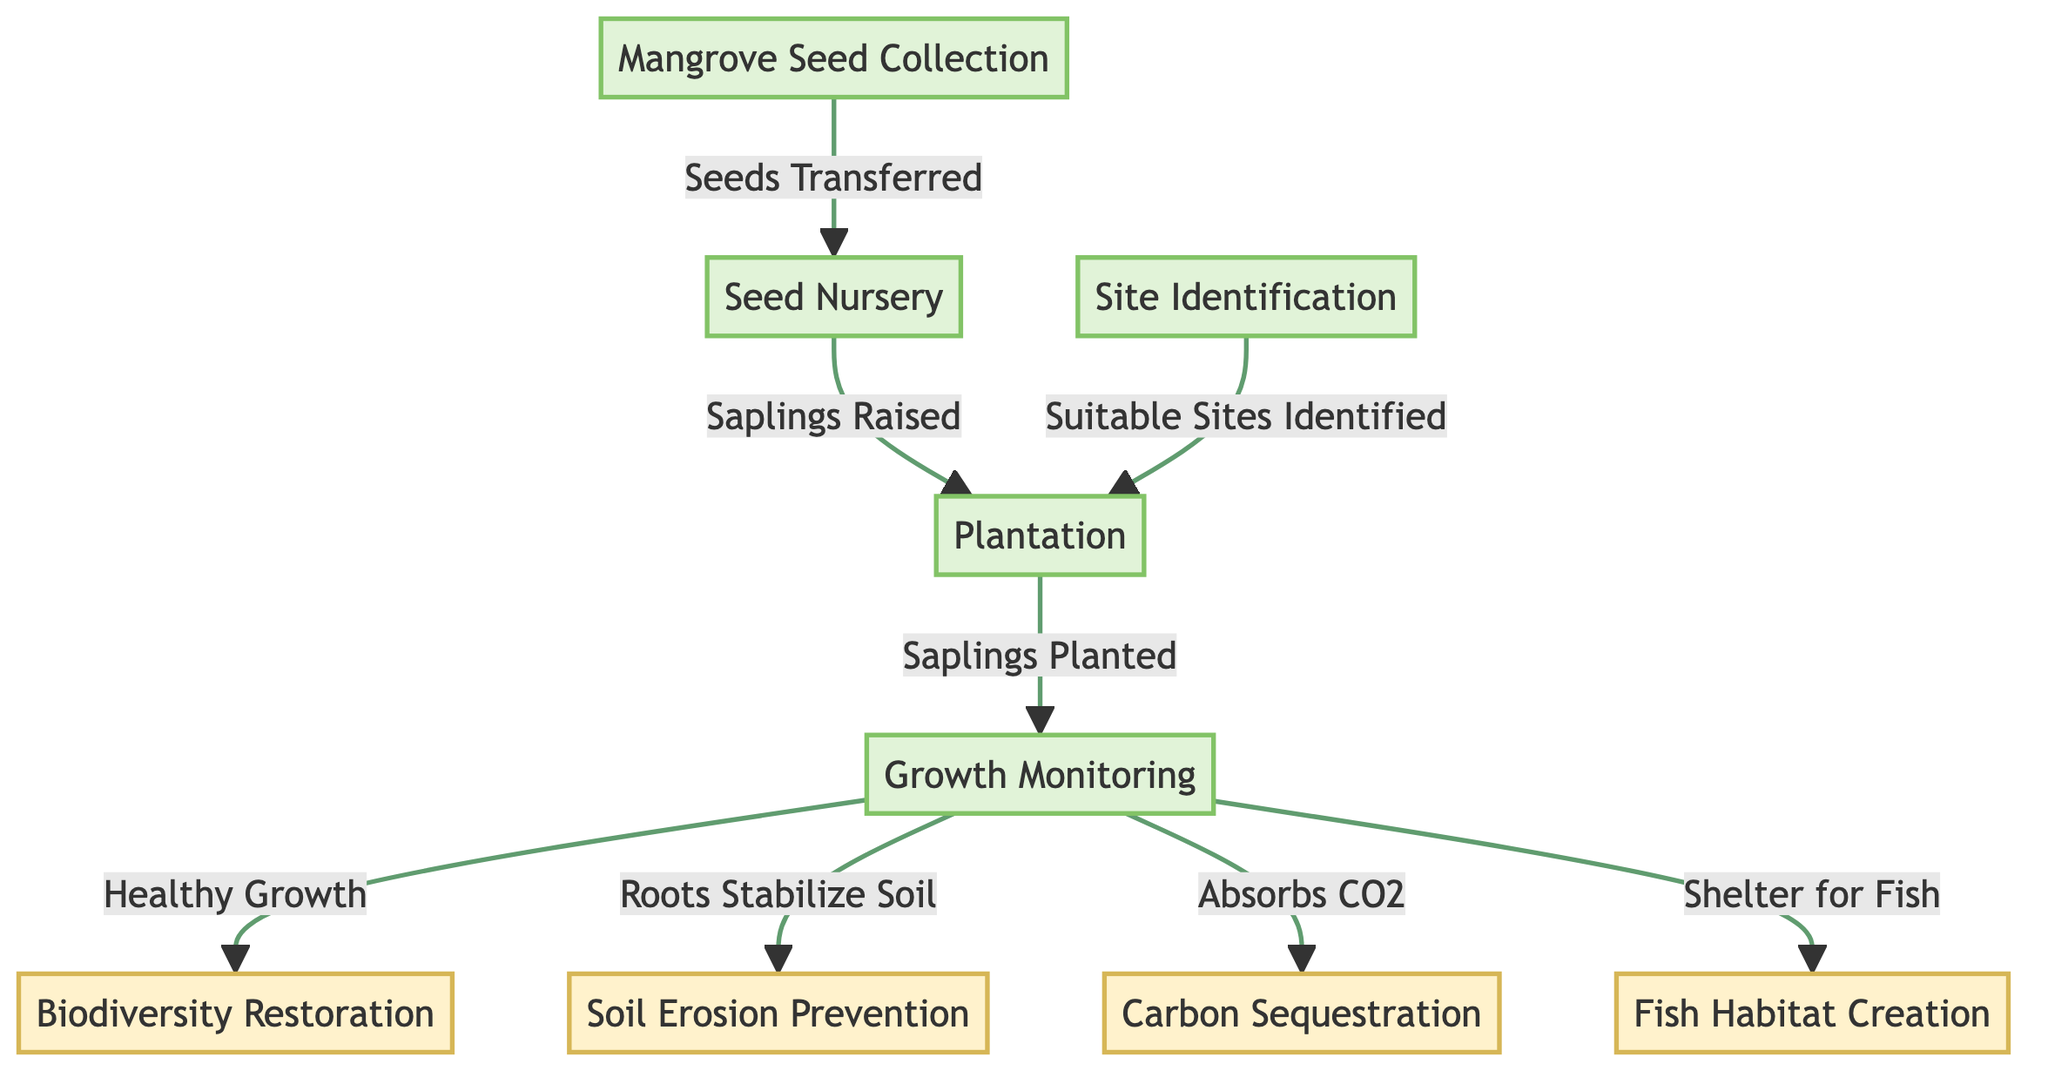What is the first step in the mangrove reforestation process? The diagram indicates that "Mangrove Seed Collection" is the first step in the process before any other actions can occur.
Answer: Mangrove Seed Collection How many benefits are listed in the diagram? By counting the nodes labeled as benefits in the diagram (Biodiversity Restoration, Soil Erosion Prevention, Carbon Sequestration, Fish Habitat Creation), we find there are four benefits presented.
Answer: 4 What action follows the "Seed Nursery"? The flowchart shows that after the "Seed Nursery," the next action that takes place is "Plantation." This indicates the sequential nature of the reforestation process.
Answer: Plantation What is the output of the growth monitoring process? The flowchart displays that the output of the "Growth Monitoring" process includes multiple benefits, specifically "Biodiversity Restoration," "Soil Erosion Prevention," "Carbon Sequestration," and "Fish Habitat Creation." Thus, the growth monitoring leads to these outputs.
Answer: Biodiversity Restoration, Soil Erosion Prevention, Carbon Sequestration, Fish Habitat Creation Which process is linked to "Roots Stabilize Soil"? By tracing the diagram, we find that "Roots Stabilize Soil" is linked to the "Growth Monitoring" process, indicating that, after monitoring growth, the roots serve the important function of stabilizing the soil.
Answer: Growth Monitoring What connects "Site Identification" to the plantation action? According to the diagram, "Site Identification" connects to the plantation action through the line indicating that it leads to "Suitable Sites Identified," which is then required for "Plantation." This illustrates how identifying suitable sites is crucial for the planting stage.
Answer: Suitable Sites Identified Which benefit is achieved by the CO2 absorption from mangroves? The diagram specifies that the benefit achieved from CO2 absorption by mangroves is "Carbon Sequestration," showing a direct relationship between the process of CO2 absorption and this environmental benefit.
Answer: Carbon Sequestration 